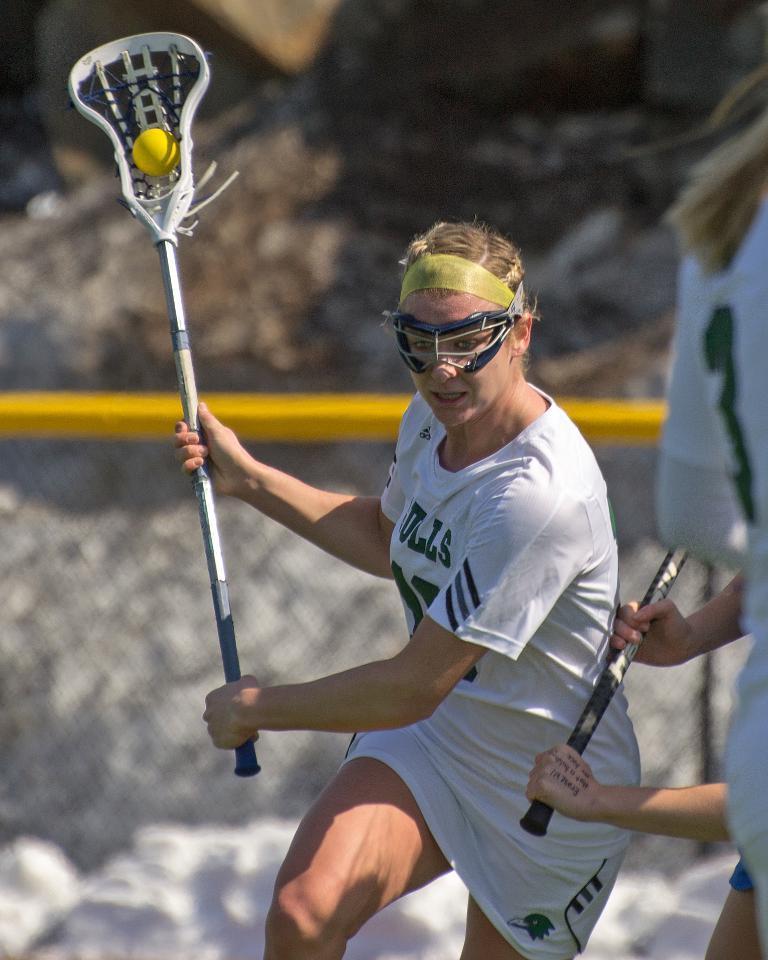How would you summarize this image in a sentence or two? In this image I can see a person playing game. The person is wearing white dress holding some object. I can also see a ball which is in yellow color, at the background I can see railing. 